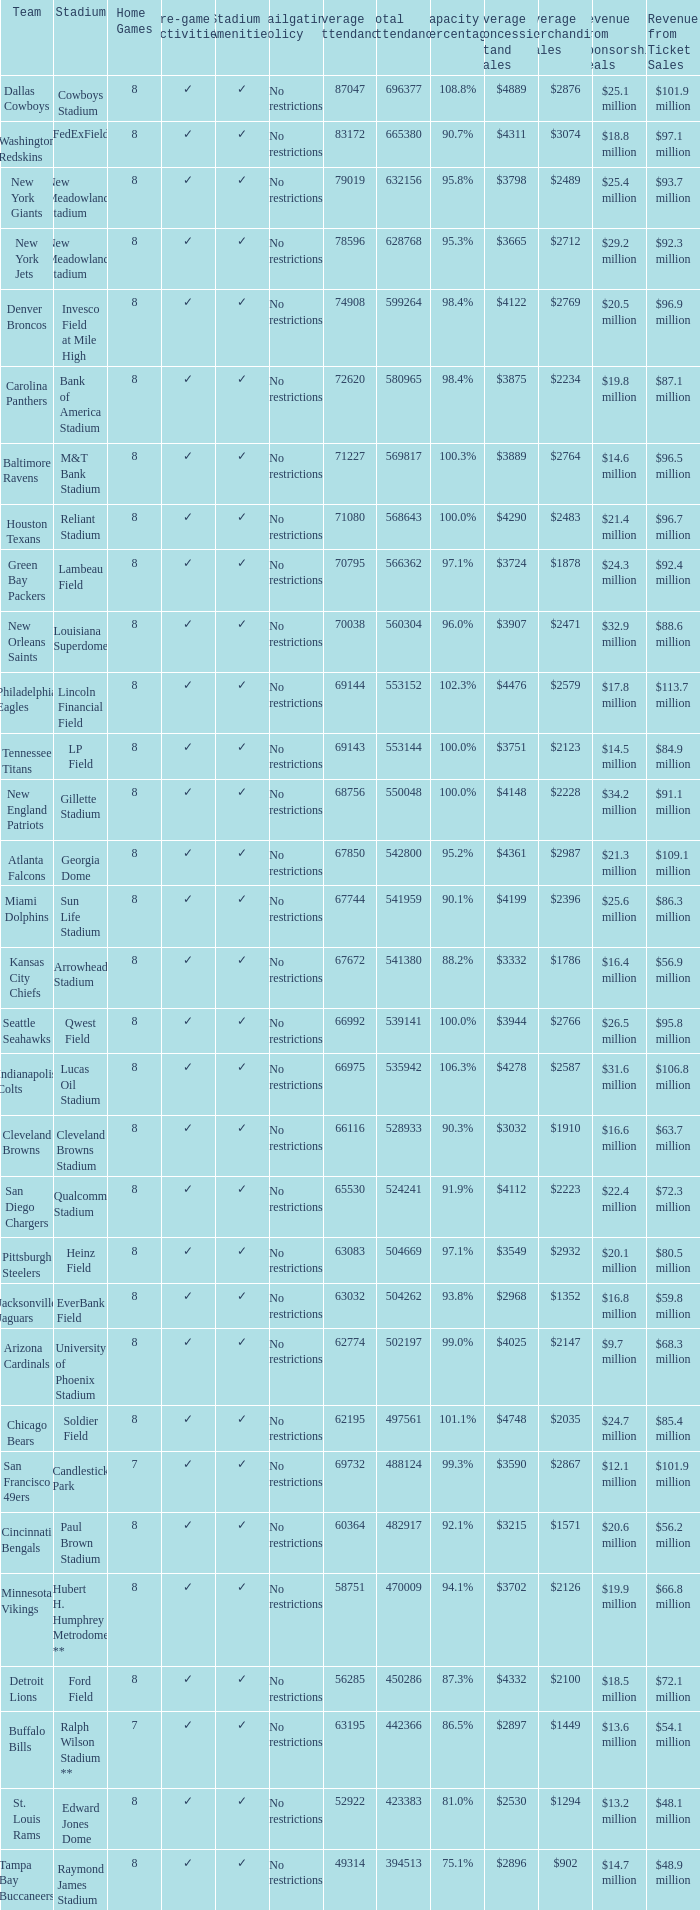Parse the table in full. {'header': ['Team', 'Stadium', 'Home Games', 'Pre-game Activities', 'Stadium Amenities', 'Tailgating Policy', 'Average Attendance', 'Total Attendance', 'Capacity Percentage', 'Average Concession Stand Sales', 'Average Merchandise Sales', 'Revenue from Sponsorship Deals', 'Revenue from Ticket Sales '], 'rows': [['Dallas Cowboys', 'Cowboys Stadium', '8', '✓', '✓', 'No restrictions', '87047', '696377', '108.8%', '$4889', '$2876', '$25.1 million', '$101.9 million'], ['Washington Redskins', 'FedExField', '8', '✓', '✓', 'No restrictions', '83172', '665380', '90.7%', '$4311', '$3074', '$18.8 million', '$97.1 million'], ['New York Giants', 'New Meadowlands Stadium', '8', '✓', '✓', 'No restrictions', '79019', '632156', '95.8%', '$3798', '$2489', '$25.4 million', '$93.7 million'], ['New York Jets', 'New Meadowlands Stadium', '8', '✓', '✓', 'No restrictions', '78596', '628768', '95.3%', '$3665', '$2712', '$29.2 million', '$92.3 million'], ['Denver Broncos', 'Invesco Field at Mile High', '8', '✓', '✓', 'No restrictions', '74908', '599264', '98.4%', '$4122', '$2769', '$20.5 million', '$96.9 million'], ['Carolina Panthers', 'Bank of America Stadium', '8', '✓', '✓', 'No restrictions', '72620', '580965', '98.4%', '$3875', '$2234', '$19.8 million', '$87.1 million'], ['Baltimore Ravens', 'M&T Bank Stadium', '8', '✓', '✓', 'No restrictions', '71227', '569817', '100.3%', '$3889', '$2764', '$14.6 million', '$96.5 million'], ['Houston Texans', 'Reliant Stadium', '8', '✓', '✓', 'No restrictions', '71080', '568643', '100.0%', '$4290', '$2483', '$21.4 million', '$96.7 million'], ['Green Bay Packers', 'Lambeau Field', '8', '✓', '✓', 'No restrictions', '70795', '566362', '97.1%', '$3724', '$1878', '$24.3 million', '$92.4 million'], ['New Orleans Saints', 'Louisiana Superdome', '8', '✓', '✓', 'No restrictions', '70038', '560304', '96.0%', '$3907', '$2471', '$32.9 million', '$88.6 million'], ['Philadelphia Eagles', 'Lincoln Financial Field', '8', '✓', '✓', 'No restrictions', '69144', '553152', '102.3%', '$4476', '$2579', '$17.8 million', '$113.7 million'], ['Tennessee Titans', 'LP Field', '8', '✓', '✓', 'No restrictions', '69143', '553144', '100.0%', '$3751', '$2123', '$14.5 million', '$84.9 million'], ['New England Patriots', 'Gillette Stadium', '8', '✓', '✓', 'No restrictions', '68756', '550048', '100.0%', '$4148', '$2228', '$34.2 million', '$91.1 million'], ['Atlanta Falcons', 'Georgia Dome', '8', '✓', '✓', 'No restrictions', '67850', '542800', '95.2%', '$4361', '$2987', '$21.3 million', '$109.1 million'], ['Miami Dolphins', 'Sun Life Stadium', '8', '✓', '✓', 'No restrictions', '67744', '541959', '90.1%', '$4199', '$2396', '$25.6 million', '$86.3 million'], ['Kansas City Chiefs', 'Arrowhead Stadium', '8', '✓', '✓', 'No restrictions', '67672', '541380', '88.2%', '$3332', '$1786', '$16.4 million', '$56.9 million'], ['Seattle Seahawks', 'Qwest Field', '8', '✓', '✓', 'No restrictions', '66992', '539141', '100.0%', '$3944', '$2766', '$26.5 million', '$95.8 million'], ['Indianapolis Colts', 'Lucas Oil Stadium', '8', '✓', '✓', 'No restrictions', '66975', '535942', '106.3%', '$4278', '$2587', '$31.6 million', '$106.8 million'], ['Cleveland Browns', 'Cleveland Browns Stadium', '8', '✓', '✓', 'No restrictions', '66116', '528933', '90.3%', '$3032', '$1910', '$16.6 million', '$63.7 million'], ['San Diego Chargers', 'Qualcomm Stadium', '8', '✓', '✓', 'No restrictions', '65530', '524241', '91.9%', '$4112', '$2223', '$22.4 million', '$72.3 million'], ['Pittsburgh Steelers', 'Heinz Field', '8', '✓', '✓', 'No restrictions', '63083', '504669', '97.1%', '$3549', '$2932', '$20.1 million', '$80.5 million'], ['Jacksonville Jaguars', 'EverBank Field', '8', '✓', '✓', 'No restrictions', '63032', '504262', '93.8%', '$2968', '$1352', '$16.8 million', '$59.8 million'], ['Arizona Cardinals', 'University of Phoenix Stadium', '8', '✓', '✓', 'No restrictions', '62774', '502197', '99.0%', '$4025', '$2147', '$9.7 million', '$68.3 million'], ['Chicago Bears', 'Soldier Field', '8', '✓', '✓', 'No restrictions', '62195', '497561', '101.1%', '$4748', '$2035', '$24.7 million', '$85.4 million'], ['San Francisco 49ers', 'Candlestick Park', '7', '✓', '✓', 'No restrictions', '69732', '488124', '99.3%', '$3590', '$2867', '$12.1 million', '$101.9 million'], ['Cincinnati Bengals', 'Paul Brown Stadium', '8', '✓', '✓', 'No restrictions', '60364', '482917', '92.1%', '$3215', '$1571', '$20.6 million', '$56.2 million'], ['Minnesota Vikings', 'Hubert H. Humphrey Metrodome **', '8', '✓', '✓', 'No restrictions', '58751', '470009', '94.1%', '$3702', '$2126', '$19.9 million', '$66.8 million'], ['Detroit Lions', 'Ford Field', '8', '✓', '✓', 'No restrictions', '56285', '450286', '87.3%', '$4332', '$2100', '$18.5 million', '$72.1 million'], ['Buffalo Bills', 'Ralph Wilson Stadium **', '7', '✓', '✓', 'No restrictions', '63195', '442366', '86.5%', '$2897', '$1449', '$13.6 million', '$54.1 million'], ['St. Louis Rams', 'Edward Jones Dome', '8', '✓', '✓', 'No restrictions', '52922', '423383', '81.0%', '$2530', '$1294', '$13.2 million', '$48.1 million'], ['Tampa Bay Buccaneers', 'Raymond James Stadium', '8', '✓', '✓', 'No restrictions', '49314', '394513', '75.1%', '$2896', '$902', '$14.7 million', '$48.9 million']]} What was the capacity for the Denver Broncos? 98.4%. 